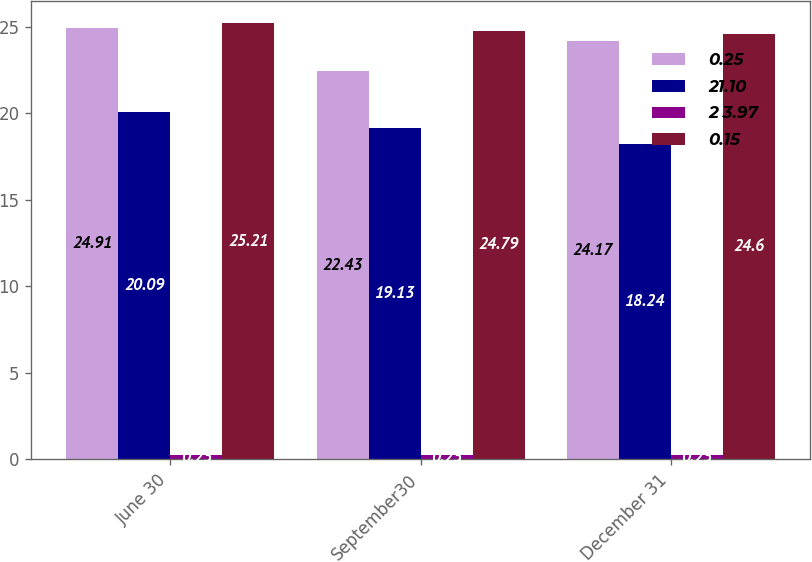<chart> <loc_0><loc_0><loc_500><loc_500><stacked_bar_chart><ecel><fcel>June 30<fcel>September30<fcel>December 31<nl><fcel>0.25<fcel>24.91<fcel>22.43<fcel>24.17<nl><fcel>21.10<fcel>20.09<fcel>19.13<fcel>18.24<nl><fcel>2 3.97<fcel>0.25<fcel>0.25<fcel>0.25<nl><fcel>0.15<fcel>25.21<fcel>24.79<fcel>24.6<nl></chart> 